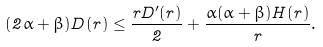<formula> <loc_0><loc_0><loc_500><loc_500>( 2 \alpha + \beta ) D ( r ) \leq \frac { r D ^ { \prime } ( r ) } { 2 } + \frac { \alpha ( \alpha + \beta ) H ( r ) } { r } .</formula> 